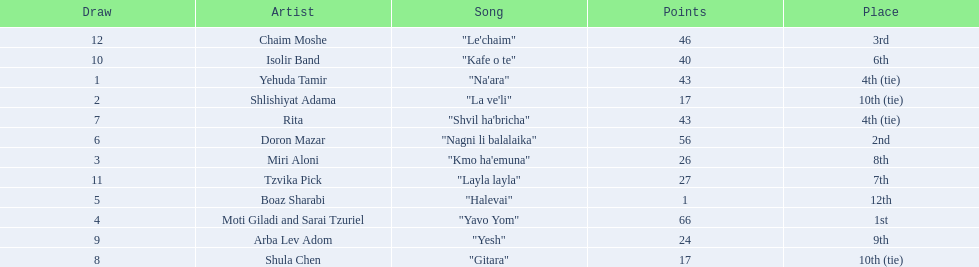What is the name of the song listed before the song "yesh"? "Gitara". 